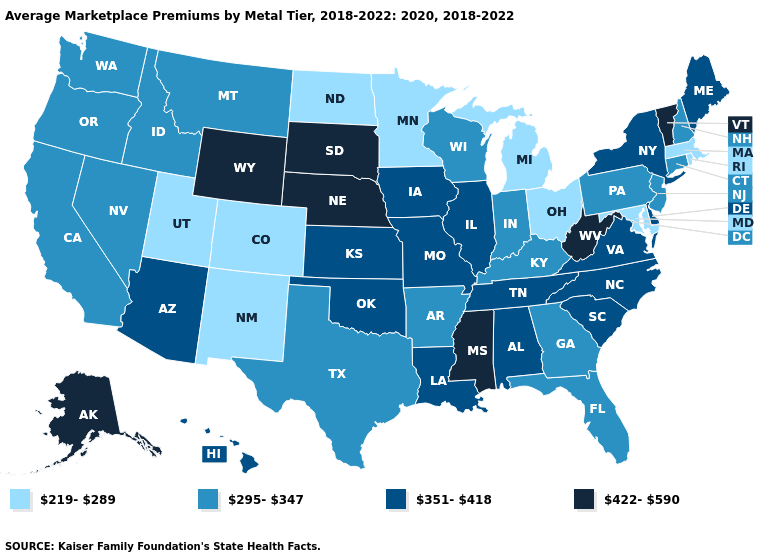What is the value of California?
Write a very short answer. 295-347. What is the value of Connecticut?
Be succinct. 295-347. What is the value of Nevada?
Keep it brief. 295-347. Which states have the lowest value in the USA?
Be succinct. Colorado, Maryland, Massachusetts, Michigan, Minnesota, New Mexico, North Dakota, Ohio, Rhode Island, Utah. What is the highest value in the USA?
Write a very short answer. 422-590. Which states have the lowest value in the USA?
Keep it brief. Colorado, Maryland, Massachusetts, Michigan, Minnesota, New Mexico, North Dakota, Ohio, Rhode Island, Utah. Name the states that have a value in the range 219-289?
Write a very short answer. Colorado, Maryland, Massachusetts, Michigan, Minnesota, New Mexico, North Dakota, Ohio, Rhode Island, Utah. Does Vermont have the highest value in the Northeast?
Be succinct. Yes. What is the value of Wyoming?
Short answer required. 422-590. Does the first symbol in the legend represent the smallest category?
Quick response, please. Yes. Does Washington have the highest value in the USA?
Short answer required. No. Does Virginia have a lower value than New Hampshire?
Keep it brief. No. What is the highest value in states that border Massachusetts?
Be succinct. 422-590. How many symbols are there in the legend?
Quick response, please. 4. 